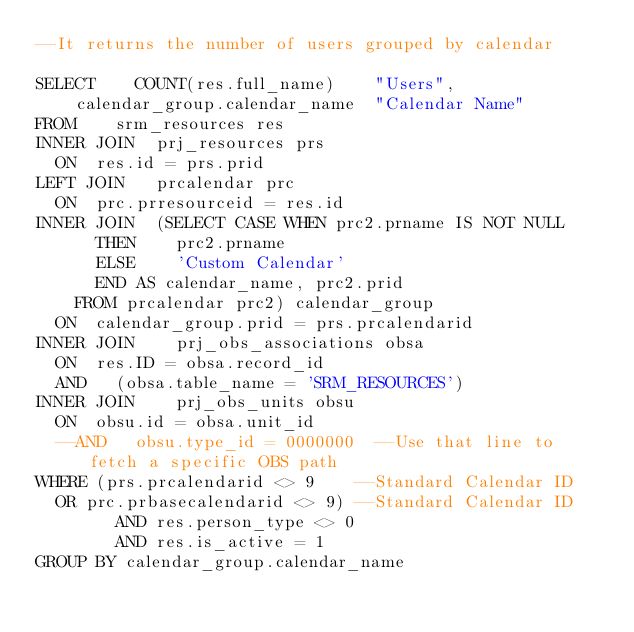Convert code to text. <code><loc_0><loc_0><loc_500><loc_500><_SQL_>--It returns the number of users grouped by calendar

SELECT		COUNT(res.full_name) 		"Users",
		calendar_group.calendar_name 	"Calendar Name"
FROM 		srm_resources res
INNER JOIN	prj_resources prs
	ON 	res.id = prs.prid
LEFT JOIN 	prcalendar prc
	ON	prc.prresourceid = res.id
INNER JOIN 	(SELECT CASE WHEN prc2.prname IS NOT NULL 
			THEN	  prc2.prname 
			ELSE 	  'Custom Calendar' 
			END AS calendar_name, prc2.prid 
		FROM prcalendar prc2) calendar_group
	ON 	calendar_group.prid = prs.prcalendarid
INNER JOIN  	prj_obs_associations obsa 
	ON 	res.ID = obsa.record_id 
	AND 	(obsa.table_name = 'SRM_RESOURCES')
INNER JOIN  	prj_obs_units obsu 
	ON 	obsu.id = obsa.unit_id 
	--AND 	obsu.type_id = 0000000 	--Use that line to fetch a specific OBS path
WHERE	(prs.prcalendarid <> 9		--Standard Calendar ID
	OR prc.prbasecalendarid <> 9)	--Standard Calendar ID
        AND res.person_type <> 0
        AND res.is_active = 1
GROUP BY calendar_group.calendar_name
</code> 